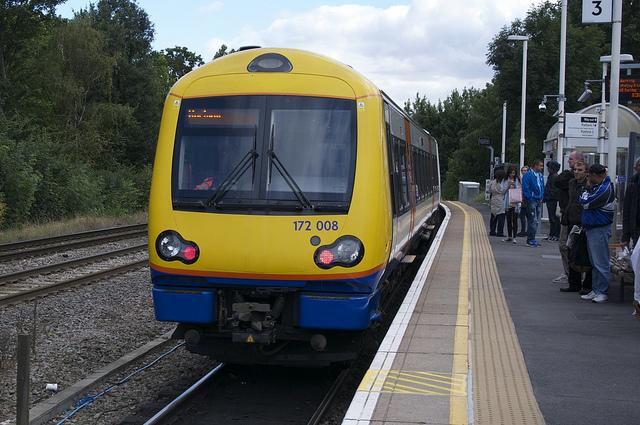Is the bus one color?
Keep it brief. No. What are the people waiting for?
Write a very short answer. Train. What is the number on the bus?
Short answer required. 172008. What does the train's number?
Be succinct. 172008. 